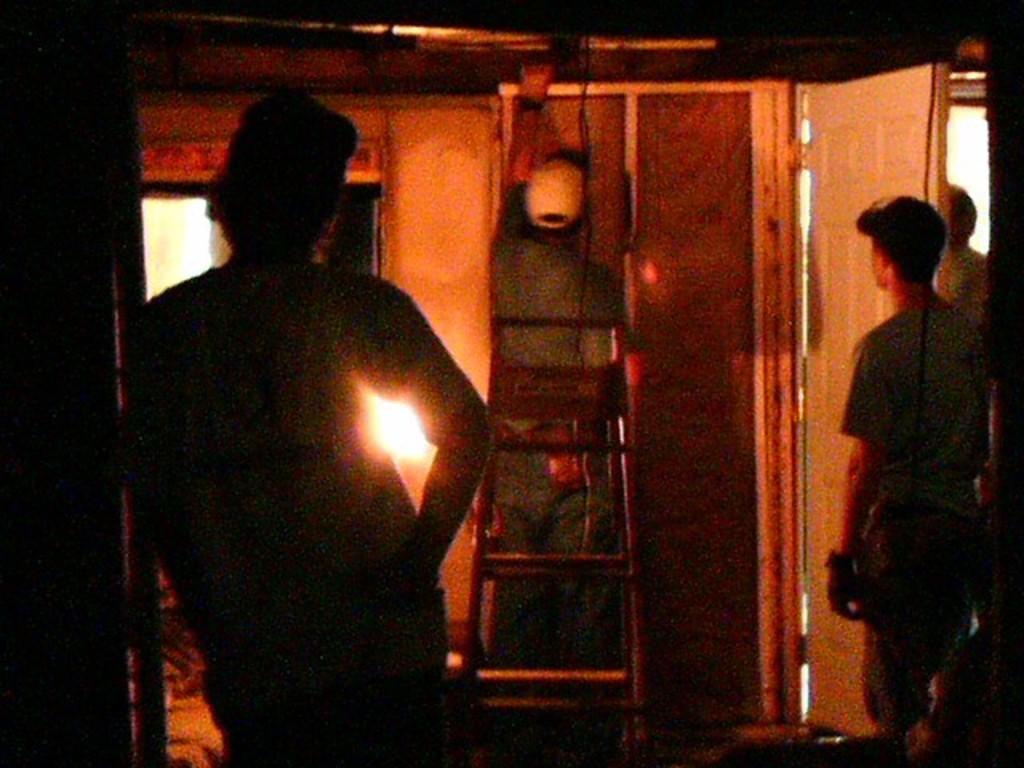Please provide a concise description of this image. In the foreground I can see three persons are standing on the floor and a person is sitting on a ladder. In the background I can see doors and a wall. This image is taken in a room. 